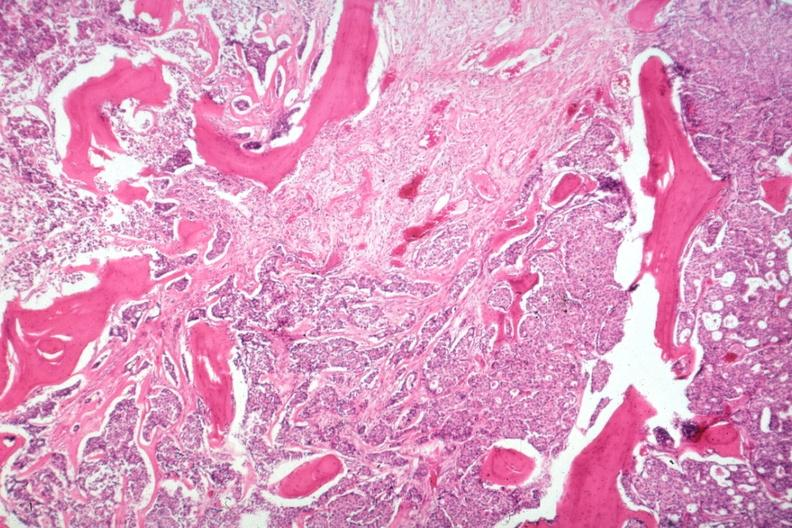what are and?
Answer the question using a single word or phrase. Additional micros 